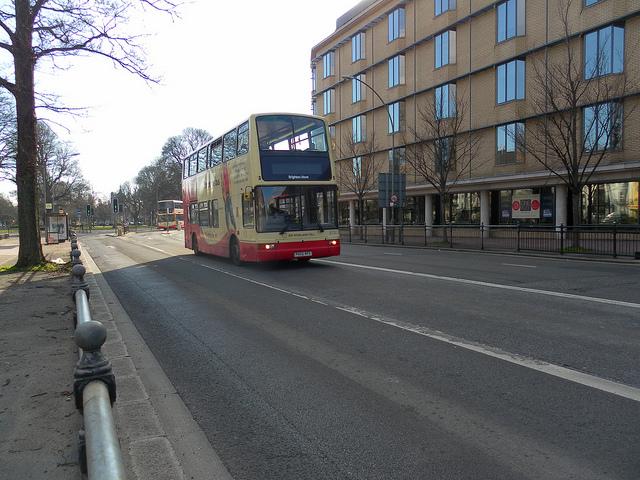What color are the trees?
Concise answer only. Brown. Is this a bus or train?
Answer briefly. Bus. What color is the bus going down the street?
Keep it brief. Red and yellow. Is the bus moving toward or away from the photographer?
Quick response, please. Toward. 